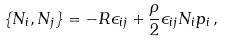<formula> <loc_0><loc_0><loc_500><loc_500>\{ N _ { i } , N _ { j } \} = - R \epsilon _ { i j } + \frac { \rho } { 2 } \epsilon _ { i j } N _ { i } p _ { i } \, ,</formula> 